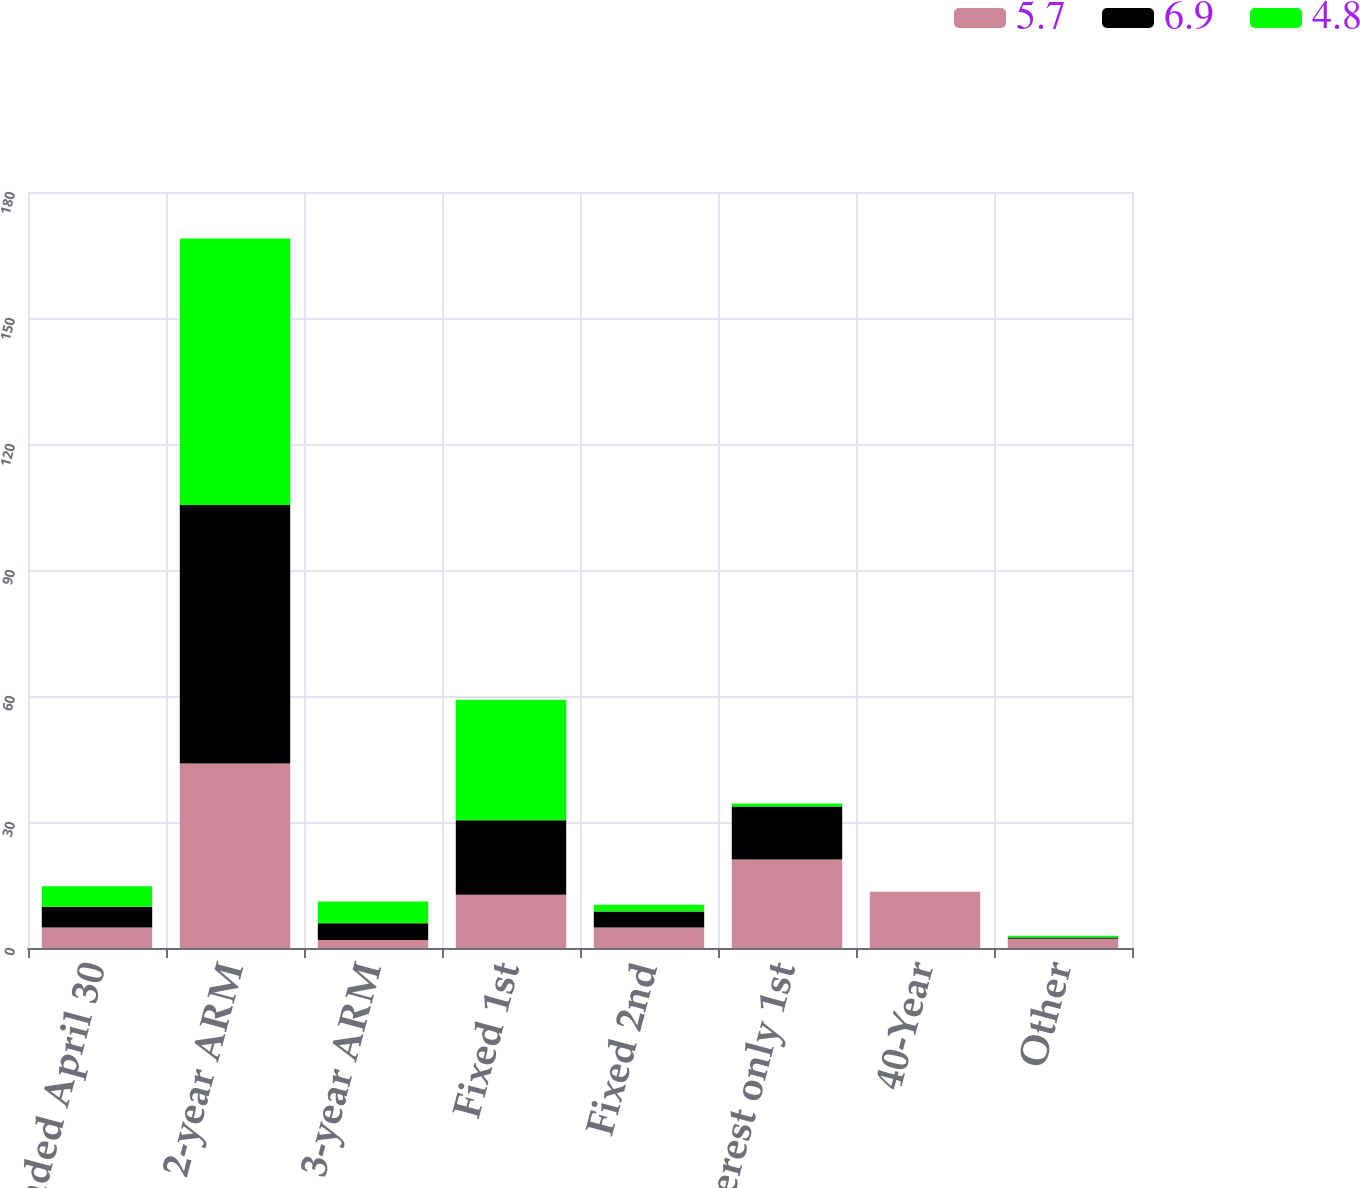Convert chart to OTSL. <chart><loc_0><loc_0><loc_500><loc_500><stacked_bar_chart><ecel><fcel>Year Ended April 30<fcel>2-year ARM<fcel>3-year ARM<fcel>Fixed 1st<fcel>Fixed 2nd<fcel>Interest only 1st<fcel>40-Year<fcel>Other<nl><fcel>5.7<fcel>4.9<fcel>43.9<fcel>1.9<fcel>12.7<fcel>4.9<fcel>21.1<fcel>13.4<fcel>2.2<nl><fcel>6.9<fcel>4.9<fcel>61.6<fcel>4<fcel>17.7<fcel>3.8<fcel>12.6<fcel>0<fcel>0.3<nl><fcel>4.8<fcel>4.9<fcel>63.4<fcel>5.2<fcel>28.7<fcel>1.6<fcel>0.7<fcel>0<fcel>0.4<nl></chart> 